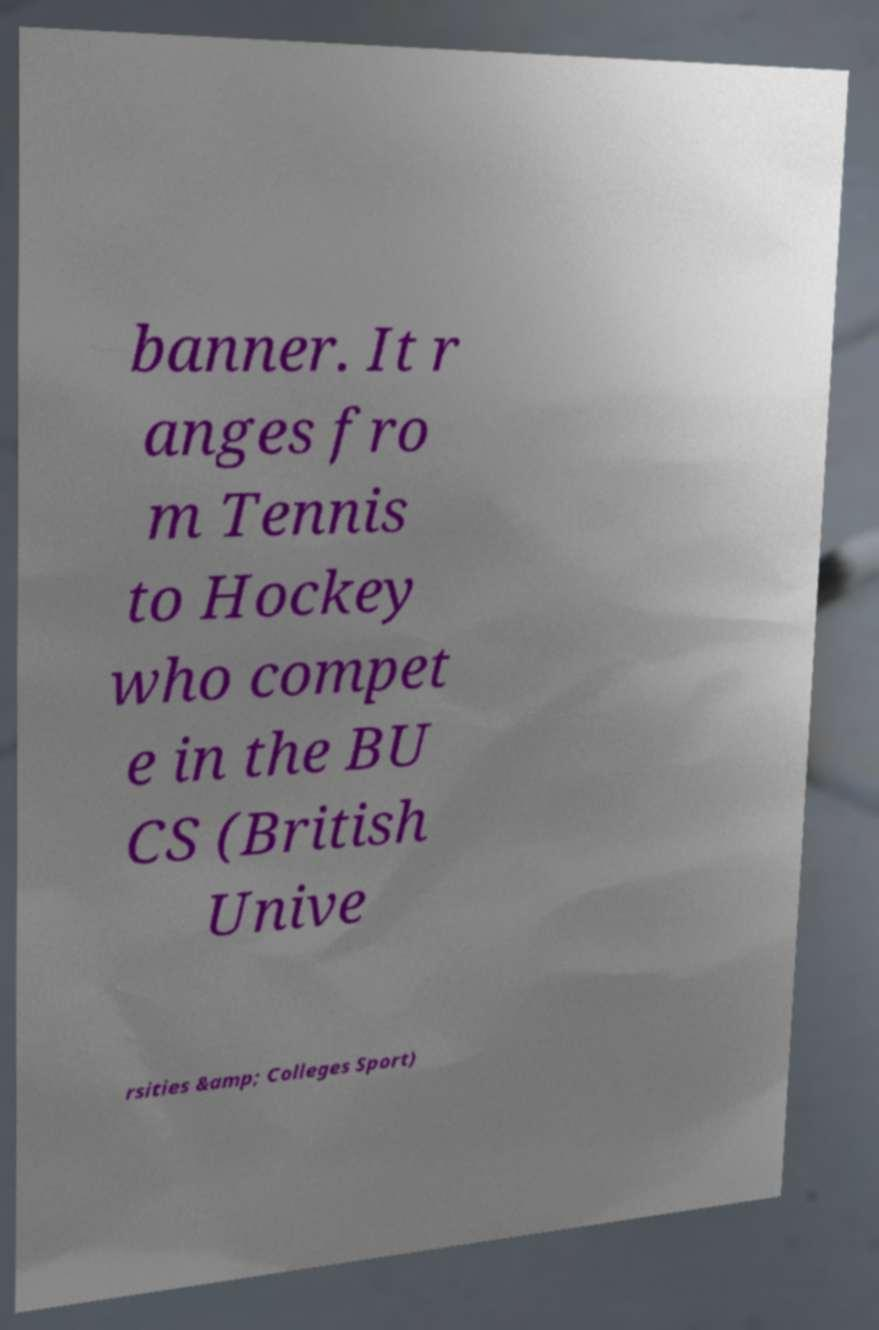Can you accurately transcribe the text from the provided image for me? banner. It r anges fro m Tennis to Hockey who compet e in the BU CS (British Unive rsities &amp; Colleges Sport) 